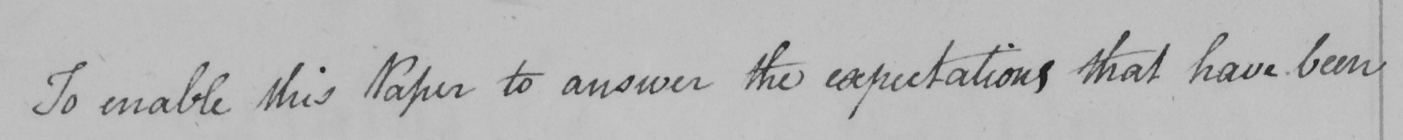What is written in this line of handwriting? To enable this Paper to answer the expectations that have been 